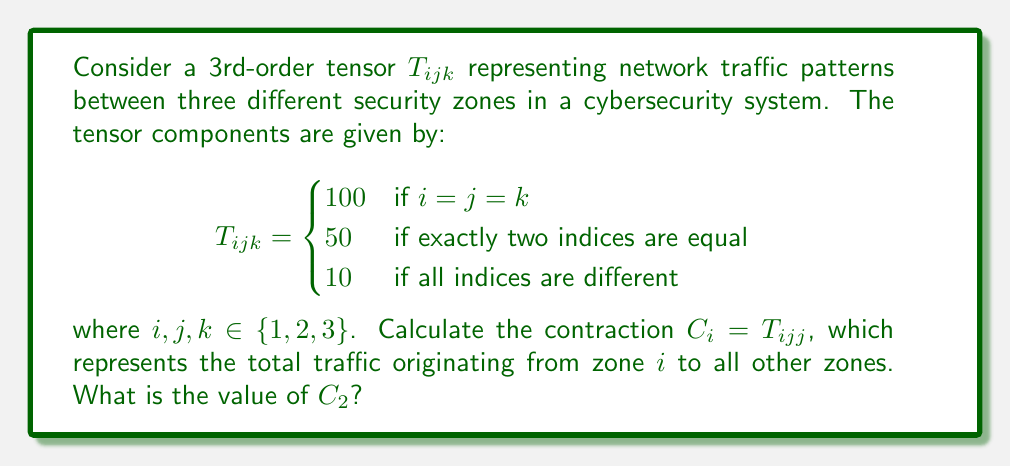Solve this math problem. To solve this problem, we need to follow these steps:

1) The contraction $C_i = T_{ijj}$ means we sum over the repeated indices $j$. In this case, we're calculating $C_2$, so $i = 2$.

2) We need to calculate:

   $C_2 = T_{211} + T_{222} + T_{233}$

3) Let's evaluate each term:

   - $T_{211}$: Here, exactly two indices are equal (1 = 1), so $T_{211} = 50$
   - $T_{222}$: All three indices are equal, so $T_{222} = 100$
   - $T_{233}$: Again, exactly two indices are equal (3 = 3), so $T_{233} = 50$

4) Now, we can sum these values:

   $C_2 = 50 + 100 + 50 = 200$

Therefore, the value of $C_2$ is 200, representing the total traffic originating from zone 2 to all zones (including itself).
Answer: $C_2 = 200$ 